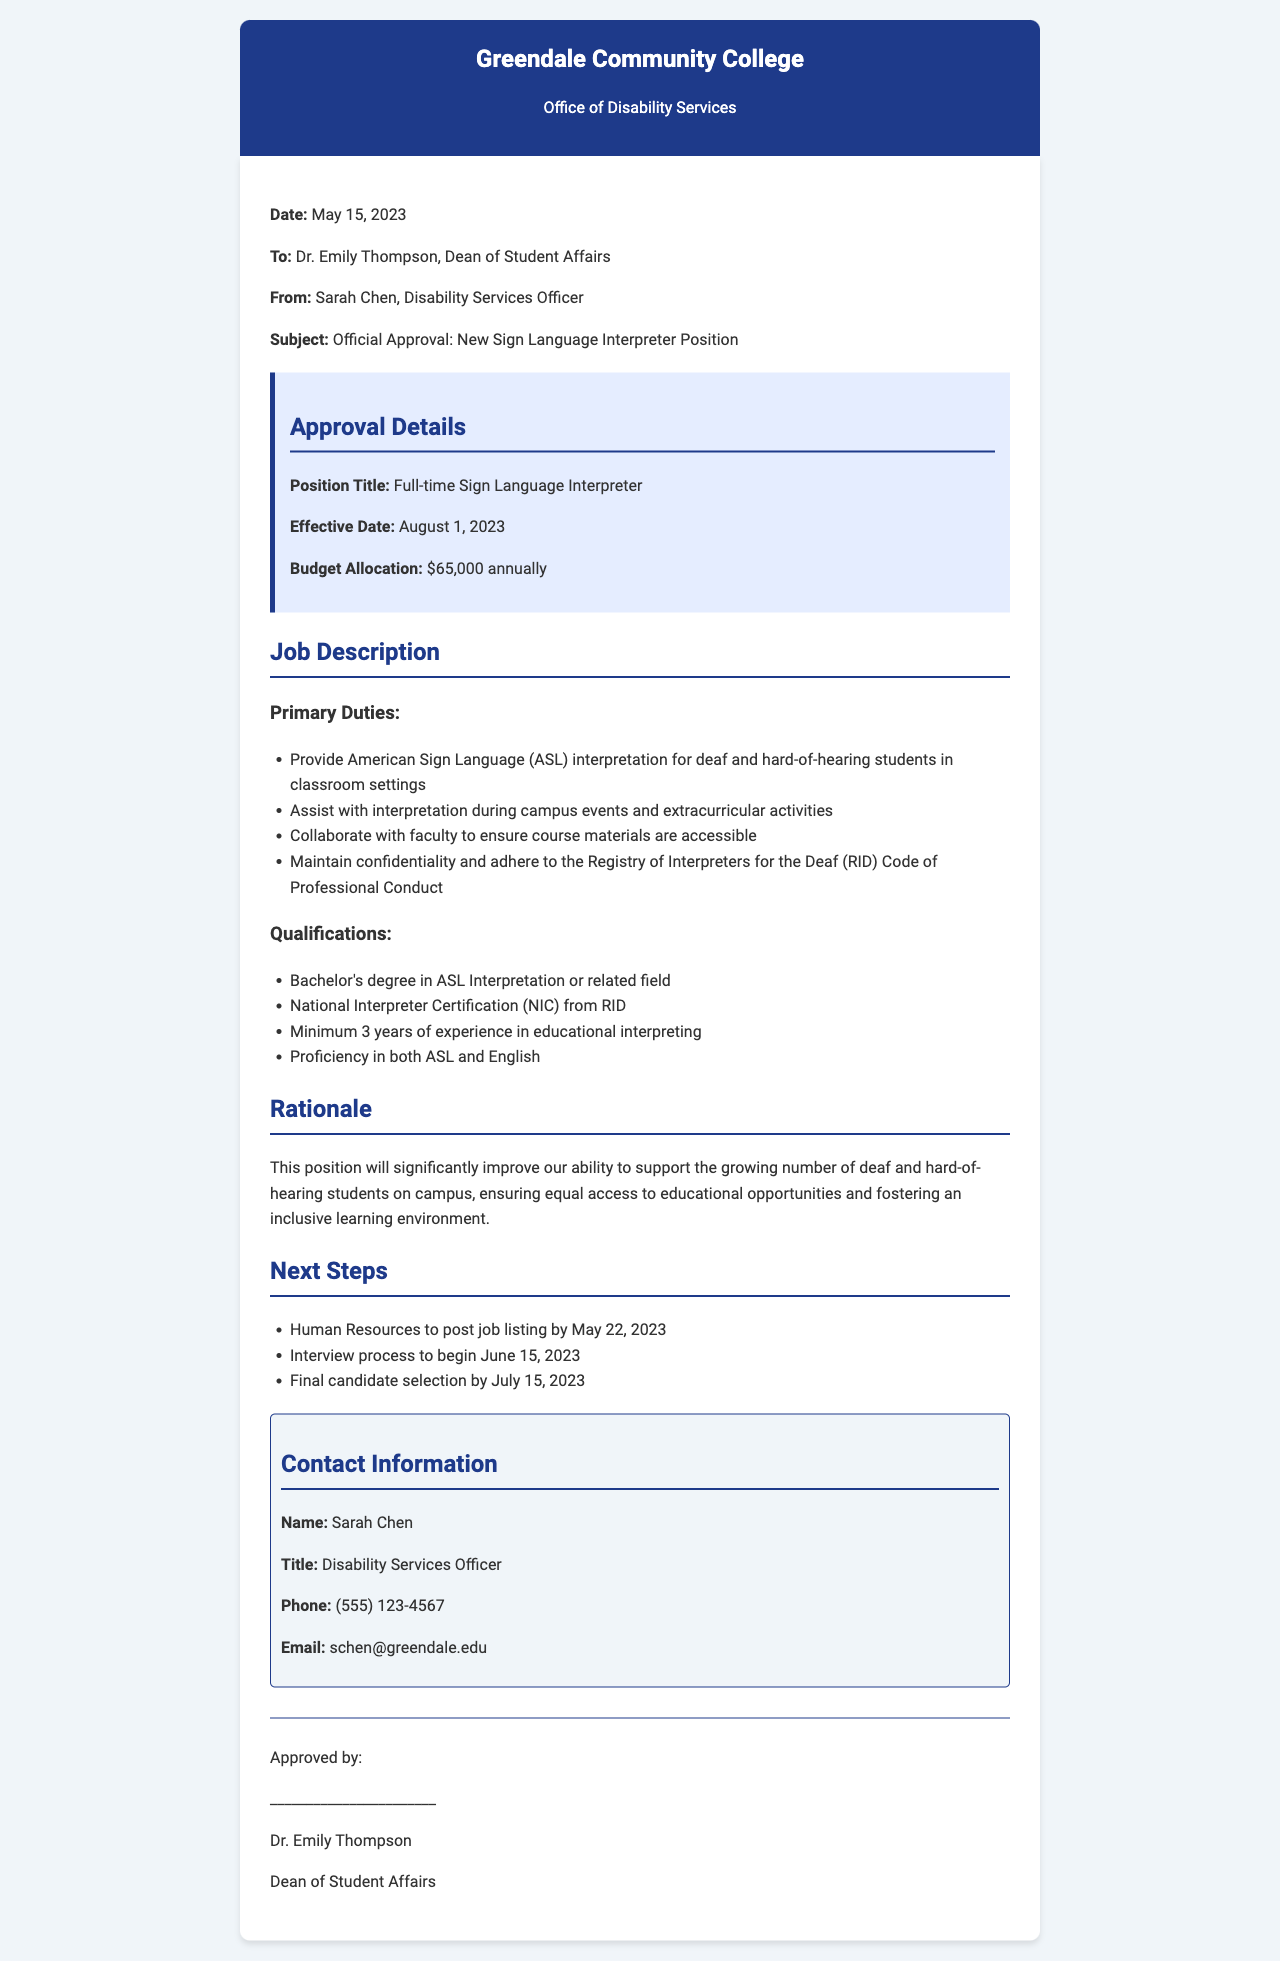What is the date of the fax? The date provided in the fax is mentioned in the header section.
Answer: May 15, 2023 Who is the recipient of the fax? The recipient is noted in the 'To' section of the document.
Answer: Dr. Emily Thompson What is the position title of the newly approved role? The title is specified in the approval details section.
Answer: Full-time Sign Language Interpreter What is the annual budget allocation for the position? The budget allocation is given in the approval details section.
Answer: $65,000 annually What is one of the primary duties of the Sign Language Interpreter? The primary duties are listed under specific bullet points in the job description.
Answer: Provide American Sign Language (ASL) interpretation for deaf and hard-of-hearing students in classroom settings What qualification is required regarding certification? The qualifications list includes specific certification requirements.
Answer: National Interpreter Certification (NIC) from RID What is the rationale for hiring a Sign Language Interpreter? The rationale is discussed in a specific section explaining the need for the position.
Answer: Improve our ability to support the growing number of deaf and hard-of-hearing students By when should the Human Resources post the job listing? This information is provided in the 'Next Steps' section of the document.
Answer: May 22, 2023 Who authored the fax? The author is identified in the 'From' section of the document.
Answer: Sarah Chen 